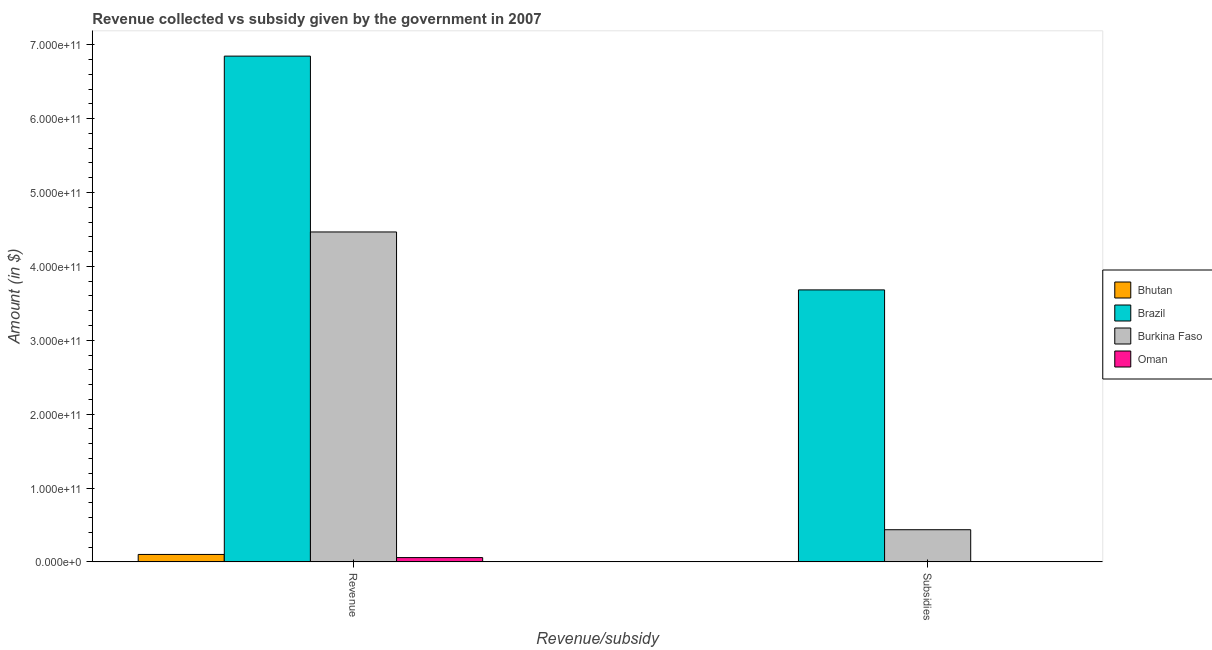How many different coloured bars are there?
Give a very brief answer. 4. Are the number of bars on each tick of the X-axis equal?
Your answer should be very brief. Yes. What is the label of the 1st group of bars from the left?
Your response must be concise. Revenue. What is the amount of subsidies given in Burkina Faso?
Give a very brief answer. 4.35e+1. Across all countries, what is the maximum amount of subsidies given?
Provide a succinct answer. 3.68e+11. Across all countries, what is the minimum amount of revenue collected?
Your answer should be compact. 5.83e+09. In which country was the amount of subsidies given minimum?
Make the answer very short. Oman. What is the total amount of revenue collected in the graph?
Make the answer very short. 1.15e+12. What is the difference between the amount of subsidies given in Burkina Faso and that in Bhutan?
Your response must be concise. 4.32e+1. What is the difference between the amount of subsidies given in Brazil and the amount of revenue collected in Bhutan?
Ensure brevity in your answer.  3.58e+11. What is the average amount of revenue collected per country?
Offer a terse response. 2.87e+11. What is the difference between the amount of subsidies given and amount of revenue collected in Bhutan?
Ensure brevity in your answer.  -9.78e+09. What is the ratio of the amount of subsidies given in Bhutan to that in Brazil?
Offer a very short reply. 0. What does the 4th bar from the left in Subsidies represents?
Your response must be concise. Oman. What does the 1st bar from the right in Subsidies represents?
Make the answer very short. Oman. How many bars are there?
Give a very brief answer. 8. Are all the bars in the graph horizontal?
Offer a very short reply. No. What is the difference between two consecutive major ticks on the Y-axis?
Your answer should be compact. 1.00e+11. Does the graph contain any zero values?
Offer a very short reply. No. Does the graph contain grids?
Give a very brief answer. No. Where does the legend appear in the graph?
Offer a terse response. Center right. How many legend labels are there?
Provide a succinct answer. 4. How are the legend labels stacked?
Your answer should be very brief. Vertical. What is the title of the graph?
Give a very brief answer. Revenue collected vs subsidy given by the government in 2007. What is the label or title of the X-axis?
Your answer should be very brief. Revenue/subsidy. What is the label or title of the Y-axis?
Provide a succinct answer. Amount (in $). What is the Amount (in $) of Bhutan in Revenue?
Your answer should be very brief. 1.01e+1. What is the Amount (in $) in Brazil in Revenue?
Offer a very short reply. 6.85e+11. What is the Amount (in $) of Burkina Faso in Revenue?
Your answer should be compact. 4.47e+11. What is the Amount (in $) in Oman in Revenue?
Offer a terse response. 5.83e+09. What is the Amount (in $) of Bhutan in Subsidies?
Offer a very short reply. 3.05e+08. What is the Amount (in $) of Brazil in Subsidies?
Make the answer very short. 3.68e+11. What is the Amount (in $) of Burkina Faso in Subsidies?
Offer a terse response. 4.35e+1. What is the Amount (in $) of Oman in Subsidies?
Your response must be concise. 2.83e+08. Across all Revenue/subsidy, what is the maximum Amount (in $) of Bhutan?
Provide a succinct answer. 1.01e+1. Across all Revenue/subsidy, what is the maximum Amount (in $) of Brazil?
Your response must be concise. 6.85e+11. Across all Revenue/subsidy, what is the maximum Amount (in $) of Burkina Faso?
Ensure brevity in your answer.  4.47e+11. Across all Revenue/subsidy, what is the maximum Amount (in $) in Oman?
Give a very brief answer. 5.83e+09. Across all Revenue/subsidy, what is the minimum Amount (in $) in Bhutan?
Provide a short and direct response. 3.05e+08. Across all Revenue/subsidy, what is the minimum Amount (in $) of Brazil?
Offer a very short reply. 3.68e+11. Across all Revenue/subsidy, what is the minimum Amount (in $) in Burkina Faso?
Keep it short and to the point. 4.35e+1. Across all Revenue/subsidy, what is the minimum Amount (in $) of Oman?
Give a very brief answer. 2.83e+08. What is the total Amount (in $) in Bhutan in the graph?
Provide a short and direct response. 1.04e+1. What is the total Amount (in $) in Brazil in the graph?
Give a very brief answer. 1.05e+12. What is the total Amount (in $) in Burkina Faso in the graph?
Offer a terse response. 4.90e+11. What is the total Amount (in $) in Oman in the graph?
Give a very brief answer. 6.12e+09. What is the difference between the Amount (in $) of Bhutan in Revenue and that in Subsidies?
Your response must be concise. 9.78e+09. What is the difference between the Amount (in $) in Brazil in Revenue and that in Subsidies?
Keep it short and to the point. 3.16e+11. What is the difference between the Amount (in $) of Burkina Faso in Revenue and that in Subsidies?
Your response must be concise. 4.03e+11. What is the difference between the Amount (in $) in Oman in Revenue and that in Subsidies?
Offer a very short reply. 5.55e+09. What is the difference between the Amount (in $) of Bhutan in Revenue and the Amount (in $) of Brazil in Subsidies?
Your answer should be very brief. -3.58e+11. What is the difference between the Amount (in $) in Bhutan in Revenue and the Amount (in $) in Burkina Faso in Subsidies?
Provide a succinct answer. -3.35e+1. What is the difference between the Amount (in $) of Bhutan in Revenue and the Amount (in $) of Oman in Subsidies?
Your response must be concise. 9.80e+09. What is the difference between the Amount (in $) of Brazil in Revenue and the Amount (in $) of Burkina Faso in Subsidies?
Make the answer very short. 6.41e+11. What is the difference between the Amount (in $) of Brazil in Revenue and the Amount (in $) of Oman in Subsidies?
Your answer should be very brief. 6.84e+11. What is the difference between the Amount (in $) of Burkina Faso in Revenue and the Amount (in $) of Oman in Subsidies?
Your answer should be very brief. 4.46e+11. What is the average Amount (in $) of Bhutan per Revenue/subsidy?
Provide a short and direct response. 5.19e+09. What is the average Amount (in $) of Brazil per Revenue/subsidy?
Ensure brevity in your answer.  5.26e+11. What is the average Amount (in $) of Burkina Faso per Revenue/subsidy?
Your answer should be compact. 2.45e+11. What is the average Amount (in $) of Oman per Revenue/subsidy?
Offer a very short reply. 3.06e+09. What is the difference between the Amount (in $) of Bhutan and Amount (in $) of Brazil in Revenue?
Your answer should be compact. -6.74e+11. What is the difference between the Amount (in $) in Bhutan and Amount (in $) in Burkina Faso in Revenue?
Ensure brevity in your answer.  -4.36e+11. What is the difference between the Amount (in $) of Bhutan and Amount (in $) of Oman in Revenue?
Ensure brevity in your answer.  4.25e+09. What is the difference between the Amount (in $) in Brazil and Amount (in $) in Burkina Faso in Revenue?
Your response must be concise. 2.38e+11. What is the difference between the Amount (in $) in Brazil and Amount (in $) in Oman in Revenue?
Make the answer very short. 6.79e+11. What is the difference between the Amount (in $) of Burkina Faso and Amount (in $) of Oman in Revenue?
Your answer should be compact. 4.41e+11. What is the difference between the Amount (in $) of Bhutan and Amount (in $) of Brazil in Subsidies?
Offer a very short reply. -3.68e+11. What is the difference between the Amount (in $) in Bhutan and Amount (in $) in Burkina Faso in Subsidies?
Offer a very short reply. -4.32e+1. What is the difference between the Amount (in $) in Bhutan and Amount (in $) in Oman in Subsidies?
Your answer should be compact. 2.16e+07. What is the difference between the Amount (in $) of Brazil and Amount (in $) of Burkina Faso in Subsidies?
Give a very brief answer. 3.25e+11. What is the difference between the Amount (in $) in Brazil and Amount (in $) in Oman in Subsidies?
Provide a short and direct response. 3.68e+11. What is the difference between the Amount (in $) in Burkina Faso and Amount (in $) in Oman in Subsidies?
Offer a very short reply. 4.33e+1. What is the ratio of the Amount (in $) in Bhutan in Revenue to that in Subsidies?
Your answer should be compact. 33.1. What is the ratio of the Amount (in $) of Brazil in Revenue to that in Subsidies?
Give a very brief answer. 1.86. What is the ratio of the Amount (in $) in Burkina Faso in Revenue to that in Subsidies?
Your answer should be compact. 10.25. What is the ratio of the Amount (in $) of Oman in Revenue to that in Subsidies?
Provide a short and direct response. 20.61. What is the difference between the highest and the second highest Amount (in $) in Bhutan?
Offer a terse response. 9.78e+09. What is the difference between the highest and the second highest Amount (in $) in Brazil?
Your answer should be very brief. 3.16e+11. What is the difference between the highest and the second highest Amount (in $) of Burkina Faso?
Your response must be concise. 4.03e+11. What is the difference between the highest and the second highest Amount (in $) in Oman?
Keep it short and to the point. 5.55e+09. What is the difference between the highest and the lowest Amount (in $) in Bhutan?
Your response must be concise. 9.78e+09. What is the difference between the highest and the lowest Amount (in $) of Brazil?
Your answer should be very brief. 3.16e+11. What is the difference between the highest and the lowest Amount (in $) in Burkina Faso?
Provide a short and direct response. 4.03e+11. What is the difference between the highest and the lowest Amount (in $) of Oman?
Ensure brevity in your answer.  5.55e+09. 